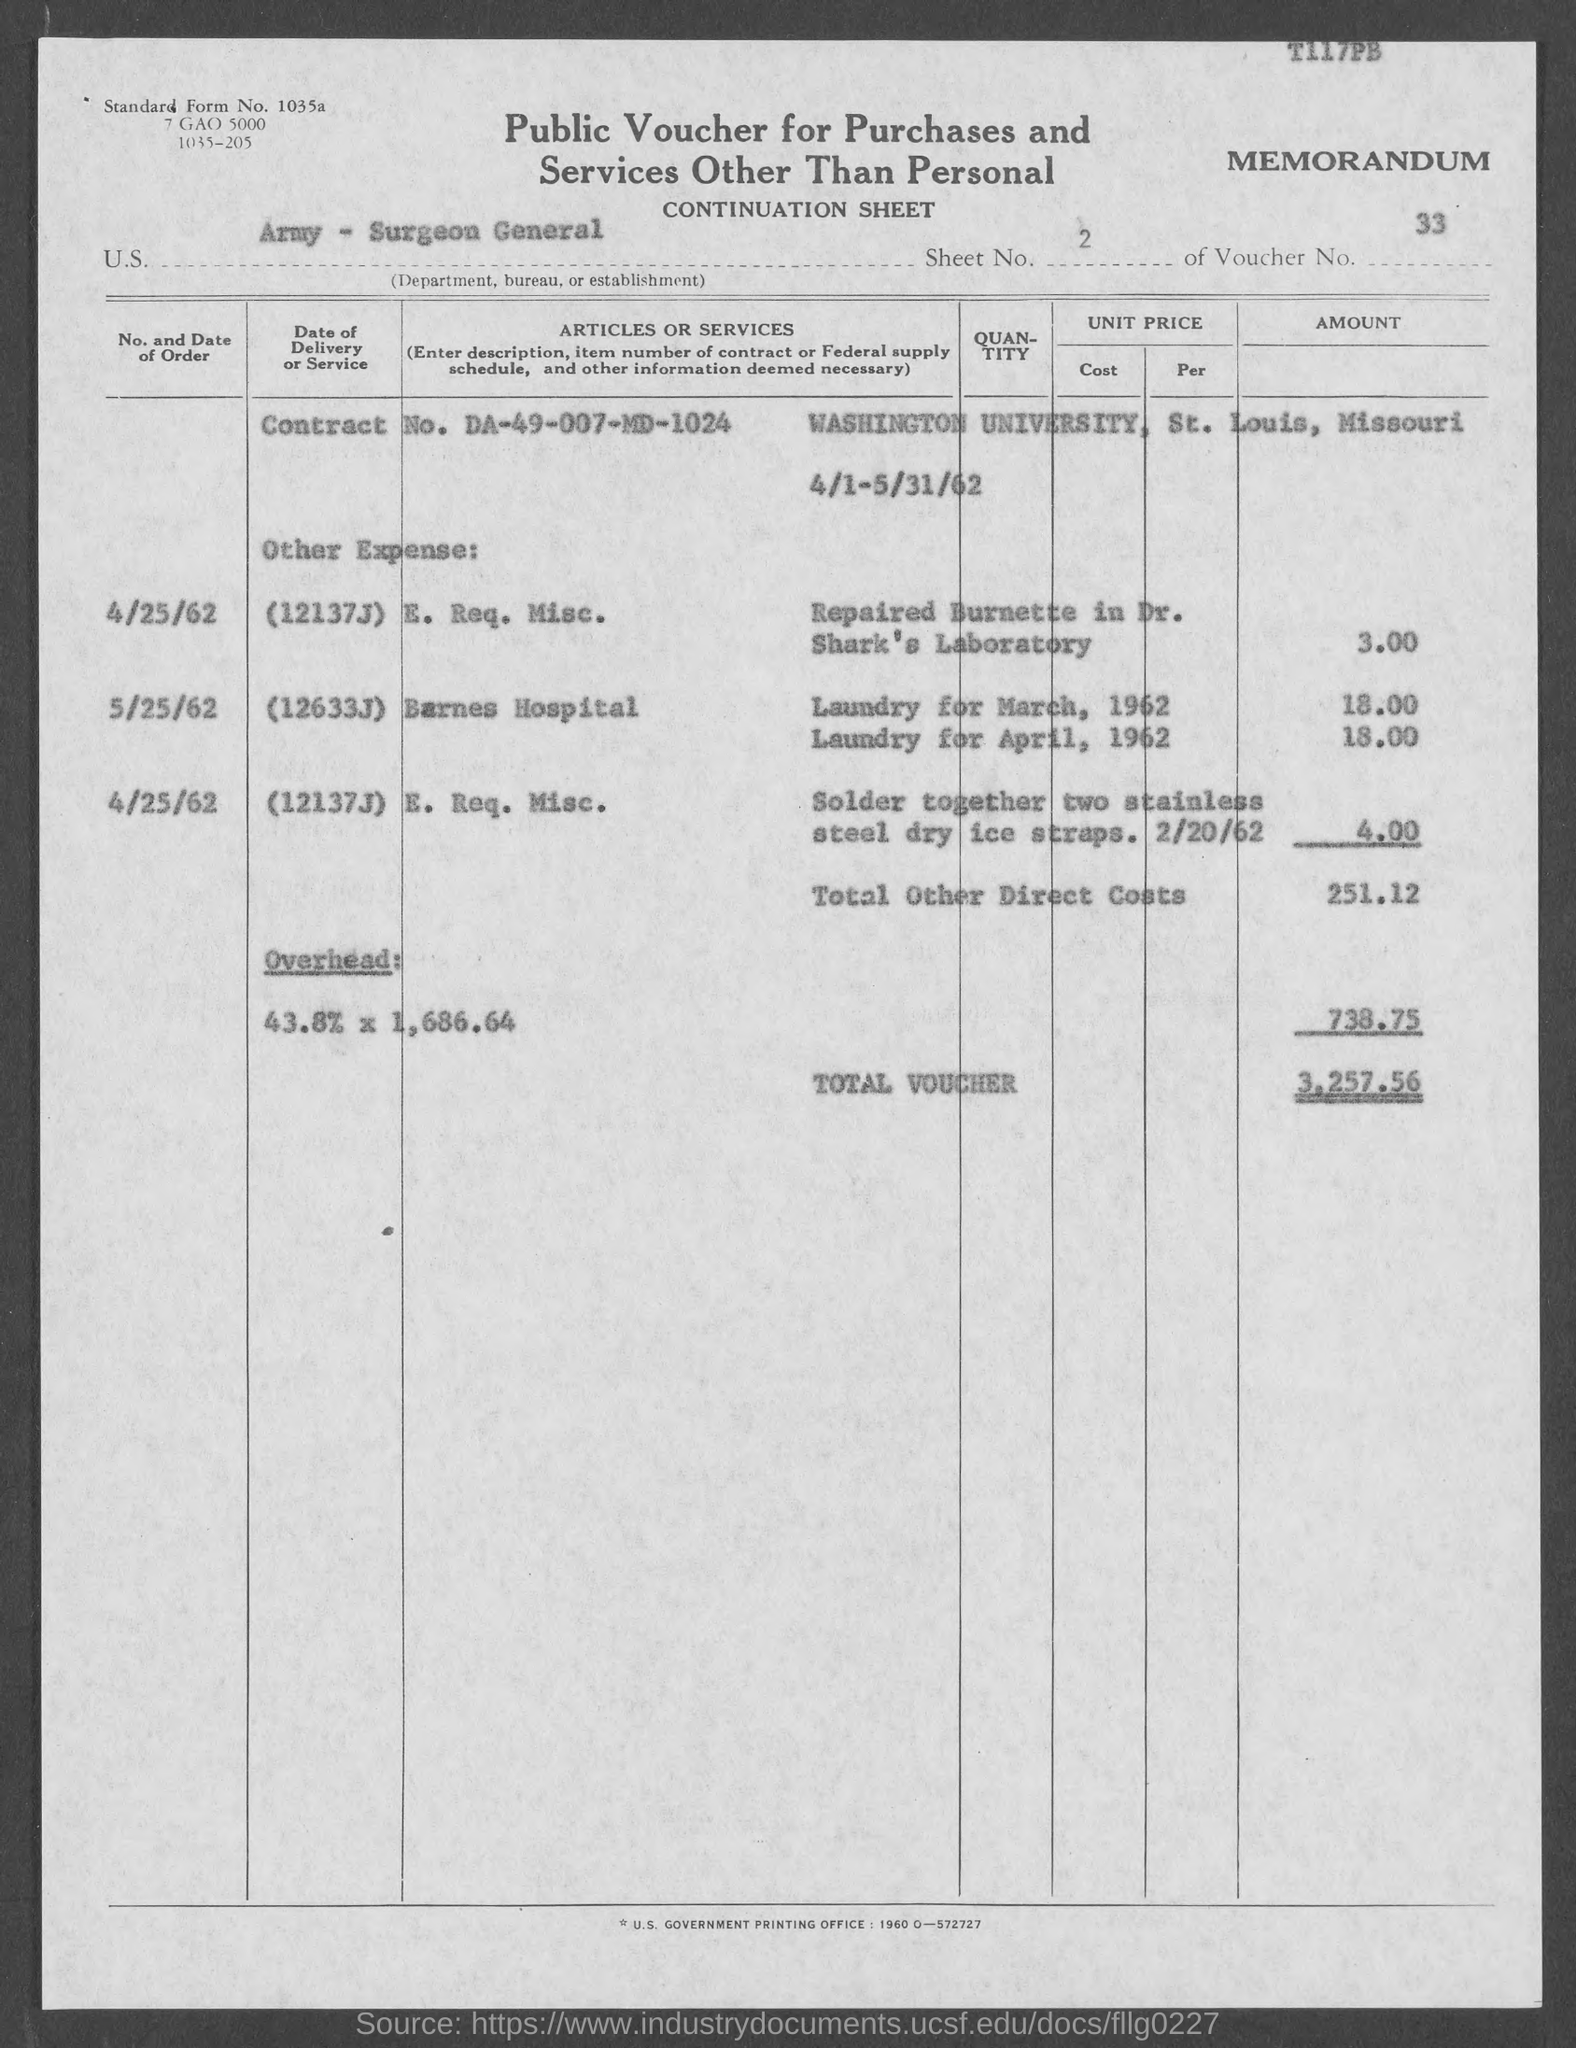Give some essential details in this illustration. The voucher number is 33. The total voucher amount is 3,257.56. 